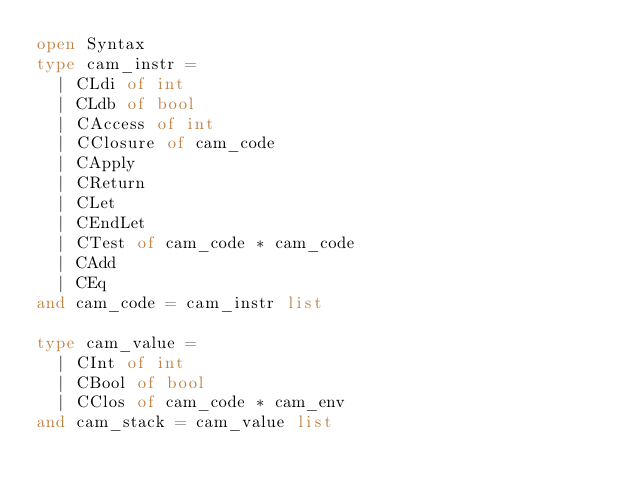<code> <loc_0><loc_0><loc_500><loc_500><_OCaml_>open Syntax
type cam_instr =
  | CLdi of int
  | CLdb of bool
  | CAccess of int
  | CClosure of cam_code
  | CApply
  | CReturn
  | CLet
  | CEndLet
  | CTest of cam_code * cam_code
  | CAdd
  | CEq
and cam_code = cam_instr list

type cam_value =
  | CInt of int
  | CBool of bool
  | CClos of cam_code * cam_env
and cam_stack = cam_value list</code> 